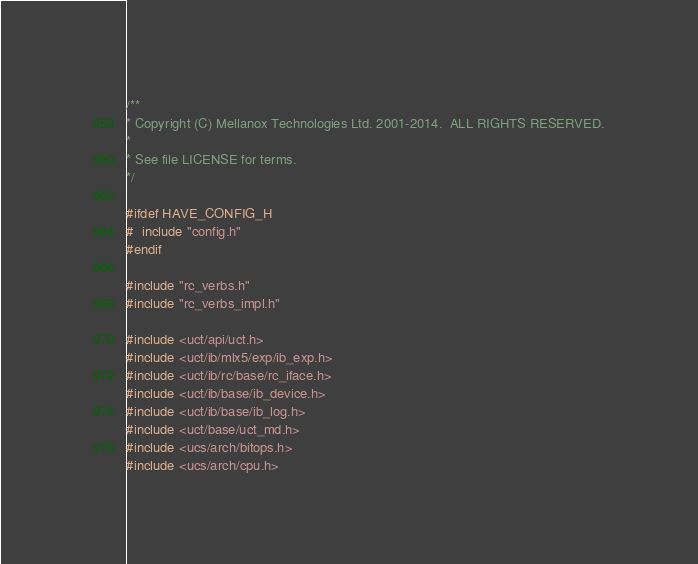Convert code to text. <code><loc_0><loc_0><loc_500><loc_500><_C_>/**
* Copyright (C) Mellanox Technologies Ltd. 2001-2014.  ALL RIGHTS RESERVED.
*
* See file LICENSE for terms.
*/

#ifdef HAVE_CONFIG_H
#  include "config.h"
#endif

#include "rc_verbs.h"
#include "rc_verbs_impl.h"

#include <uct/api/uct.h>
#include <uct/ib/mlx5/exp/ib_exp.h>
#include <uct/ib/rc/base/rc_iface.h>
#include <uct/ib/base/ib_device.h>
#include <uct/ib/base/ib_log.h>
#include <uct/base/uct_md.h>
#include <ucs/arch/bitops.h>
#include <ucs/arch/cpu.h></code> 